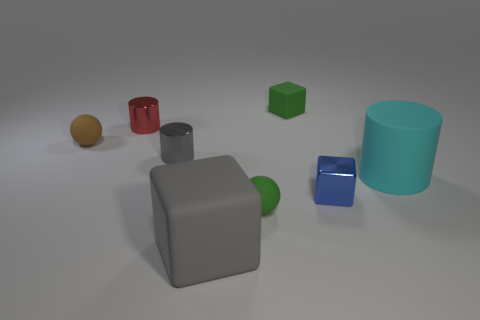Subtract all blue cubes. How many cubes are left? 2 Subtract all gray blocks. How many blocks are left? 2 Add 2 small brown things. How many objects exist? 10 Subtract all cylinders. How many objects are left? 5 Add 4 tiny red shiny cubes. How many tiny red shiny cubes exist? 4 Subtract 0 yellow cylinders. How many objects are left? 8 Subtract 2 blocks. How many blocks are left? 1 Subtract all brown balls. Subtract all cyan cylinders. How many balls are left? 1 Subtract all brown cubes. How many brown spheres are left? 1 Subtract all large gray matte blocks. Subtract all small green spheres. How many objects are left? 6 